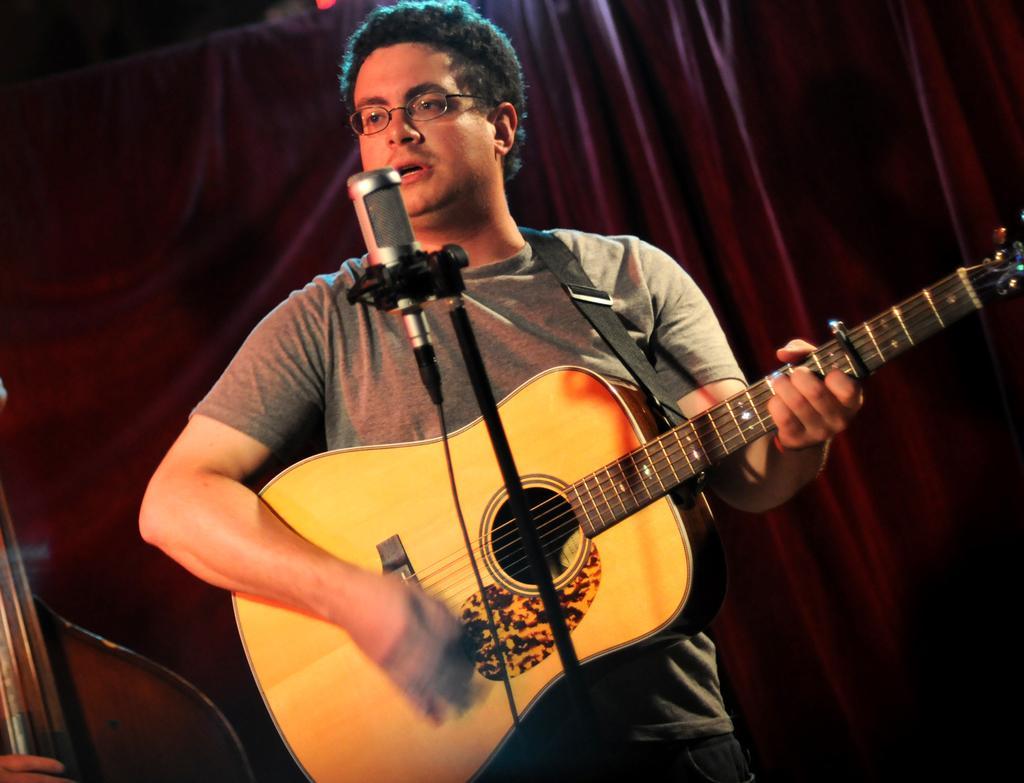Describe this image in one or two sentences. Here we can see a man playing guitar and singing a song with a microphone in front of him 